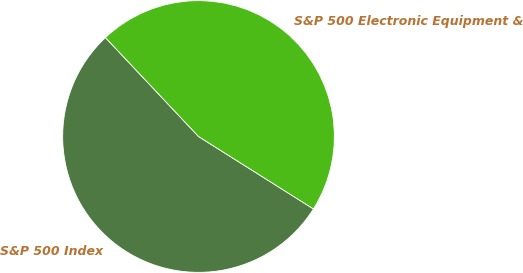Convert chart to OTSL. <chart><loc_0><loc_0><loc_500><loc_500><pie_chart><fcel>S&P 500 Index<fcel>S&P 500 Electronic Equipment &<nl><fcel>54.03%<fcel>45.97%<nl></chart> 